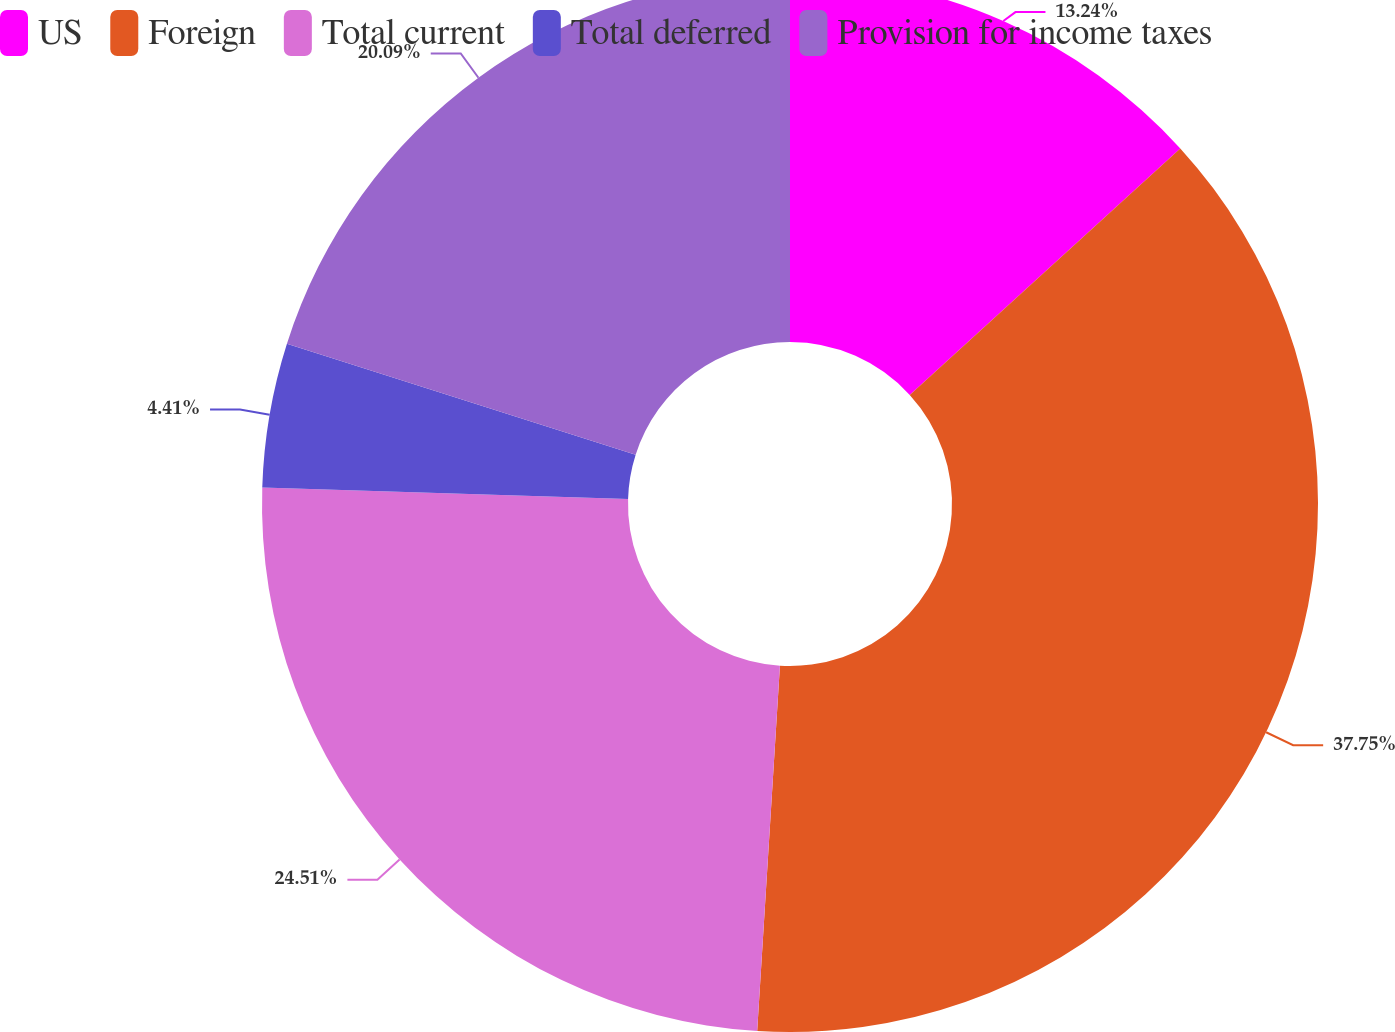Convert chart to OTSL. <chart><loc_0><loc_0><loc_500><loc_500><pie_chart><fcel>US<fcel>Foreign<fcel>Total current<fcel>Total deferred<fcel>Provision for income taxes<nl><fcel>13.24%<fcel>37.75%<fcel>24.51%<fcel>4.41%<fcel>20.09%<nl></chart> 